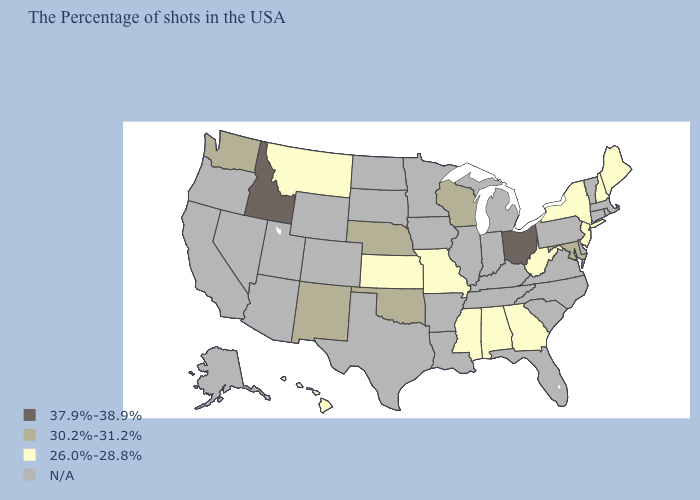Among the states that border Oregon , does Washington have the highest value?
Quick response, please. No. Is the legend a continuous bar?
Concise answer only. No. What is the value of Arizona?
Quick response, please. N/A. Does Missouri have the lowest value in the MidWest?
Give a very brief answer. Yes. Name the states that have a value in the range N/A?
Keep it brief. Massachusetts, Rhode Island, Vermont, Connecticut, Delaware, Pennsylvania, Virginia, North Carolina, South Carolina, Florida, Michigan, Kentucky, Indiana, Tennessee, Illinois, Louisiana, Arkansas, Minnesota, Iowa, Texas, South Dakota, North Dakota, Wyoming, Colorado, Utah, Arizona, Nevada, California, Oregon, Alaska. What is the lowest value in the Northeast?
Give a very brief answer. 26.0%-28.8%. Which states have the lowest value in the West?
Short answer required. Montana, Hawaii. Does Missouri have the lowest value in the USA?
Short answer required. Yes. What is the value of Texas?
Answer briefly. N/A. Name the states that have a value in the range 37.9%-38.9%?
Keep it brief. Ohio, Idaho. Which states have the highest value in the USA?
Keep it brief. Ohio, Idaho. Does Wisconsin have the lowest value in the MidWest?
Keep it brief. No. Name the states that have a value in the range N/A?
Short answer required. Massachusetts, Rhode Island, Vermont, Connecticut, Delaware, Pennsylvania, Virginia, North Carolina, South Carolina, Florida, Michigan, Kentucky, Indiana, Tennessee, Illinois, Louisiana, Arkansas, Minnesota, Iowa, Texas, South Dakota, North Dakota, Wyoming, Colorado, Utah, Arizona, Nevada, California, Oregon, Alaska. 